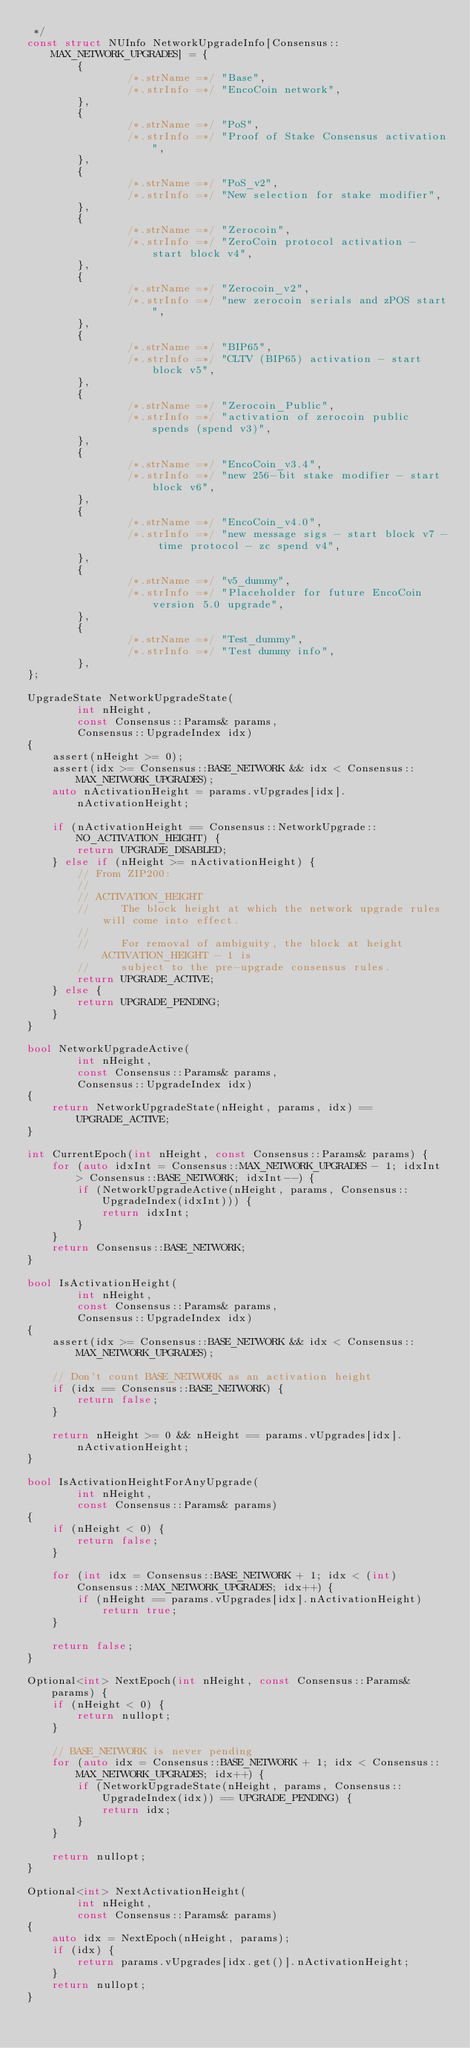<code> <loc_0><loc_0><loc_500><loc_500><_C++_> */
const struct NUInfo NetworkUpgradeInfo[Consensus::MAX_NETWORK_UPGRADES] = {
        {
                /*.strName =*/ "Base",
                /*.strInfo =*/ "EncoCoin network",
        },
        {
                /*.strName =*/ "PoS",
                /*.strInfo =*/ "Proof of Stake Consensus activation",
        },
        {
                /*.strName =*/ "PoS_v2",
                /*.strInfo =*/ "New selection for stake modifier",
        },
        {
                /*.strName =*/ "Zerocoin",
                /*.strInfo =*/ "ZeroCoin protocol activation - start block v4",
        },
        {
                /*.strName =*/ "Zerocoin_v2",
                /*.strInfo =*/ "new zerocoin serials and zPOS start",
        },
        {
                /*.strName =*/ "BIP65",
                /*.strInfo =*/ "CLTV (BIP65) activation - start block v5",
        },
        {
                /*.strName =*/ "Zerocoin_Public",
                /*.strInfo =*/ "activation of zerocoin public spends (spend v3)",
        },
        {
                /*.strName =*/ "EncoCoin_v3.4",
                /*.strInfo =*/ "new 256-bit stake modifier - start block v6",
        },
        {
                /*.strName =*/ "EncoCoin_v4.0",
                /*.strInfo =*/ "new message sigs - start block v7 - time protocol - zc spend v4",
        },
        {
                /*.strName =*/ "v5_dummy",
                /*.strInfo =*/ "Placeholder for future EncoCoin version 5.0 upgrade",
        },
        {
                /*.strName =*/ "Test_dummy",
                /*.strInfo =*/ "Test dummy info",
        },
};

UpgradeState NetworkUpgradeState(
        int nHeight,
        const Consensus::Params& params,
        Consensus::UpgradeIndex idx)
{
    assert(nHeight >= 0);
    assert(idx >= Consensus::BASE_NETWORK && idx < Consensus::MAX_NETWORK_UPGRADES);
    auto nActivationHeight = params.vUpgrades[idx].nActivationHeight;

    if (nActivationHeight == Consensus::NetworkUpgrade::NO_ACTIVATION_HEIGHT) {
        return UPGRADE_DISABLED;
    } else if (nHeight >= nActivationHeight) {
        // From ZIP200:
        //
        // ACTIVATION_HEIGHT
        //     The block height at which the network upgrade rules will come into effect.
        //
        //     For removal of ambiguity, the block at height ACTIVATION_HEIGHT - 1 is
        //     subject to the pre-upgrade consensus rules.
        return UPGRADE_ACTIVE;
    } else {
        return UPGRADE_PENDING;
    }
}

bool NetworkUpgradeActive(
        int nHeight,
        const Consensus::Params& params,
        Consensus::UpgradeIndex idx)
{
    return NetworkUpgradeState(nHeight, params, idx) == UPGRADE_ACTIVE;
}

int CurrentEpoch(int nHeight, const Consensus::Params& params) {
    for (auto idxInt = Consensus::MAX_NETWORK_UPGRADES - 1; idxInt > Consensus::BASE_NETWORK; idxInt--) {
        if (NetworkUpgradeActive(nHeight, params, Consensus::UpgradeIndex(idxInt))) {
            return idxInt;
        }
    }
    return Consensus::BASE_NETWORK;
}

bool IsActivationHeight(
        int nHeight,
        const Consensus::Params& params,
        Consensus::UpgradeIndex idx)
{
    assert(idx >= Consensus::BASE_NETWORK && idx < Consensus::MAX_NETWORK_UPGRADES);

    // Don't count BASE_NETWORK as an activation height
    if (idx == Consensus::BASE_NETWORK) {
        return false;
    }

    return nHeight >= 0 && nHeight == params.vUpgrades[idx].nActivationHeight;
}

bool IsActivationHeightForAnyUpgrade(
        int nHeight,
        const Consensus::Params& params)
{
    if (nHeight < 0) {
        return false;
    }

    for (int idx = Consensus::BASE_NETWORK + 1; idx < (int) Consensus::MAX_NETWORK_UPGRADES; idx++) {
        if (nHeight == params.vUpgrades[idx].nActivationHeight)
            return true;
    }

    return false;
}

Optional<int> NextEpoch(int nHeight, const Consensus::Params& params) {
    if (nHeight < 0) {
        return nullopt;
    }

    // BASE_NETWORK is never pending
    for (auto idx = Consensus::BASE_NETWORK + 1; idx < Consensus::MAX_NETWORK_UPGRADES; idx++) {
        if (NetworkUpgradeState(nHeight, params, Consensus::UpgradeIndex(idx)) == UPGRADE_PENDING) {
            return idx;
        }
    }

    return nullopt;
}

Optional<int> NextActivationHeight(
        int nHeight,
        const Consensus::Params& params)
{
    auto idx = NextEpoch(nHeight, params);
    if (idx) {
        return params.vUpgrades[idx.get()].nActivationHeight;
    }
    return nullopt;
}
</code> 